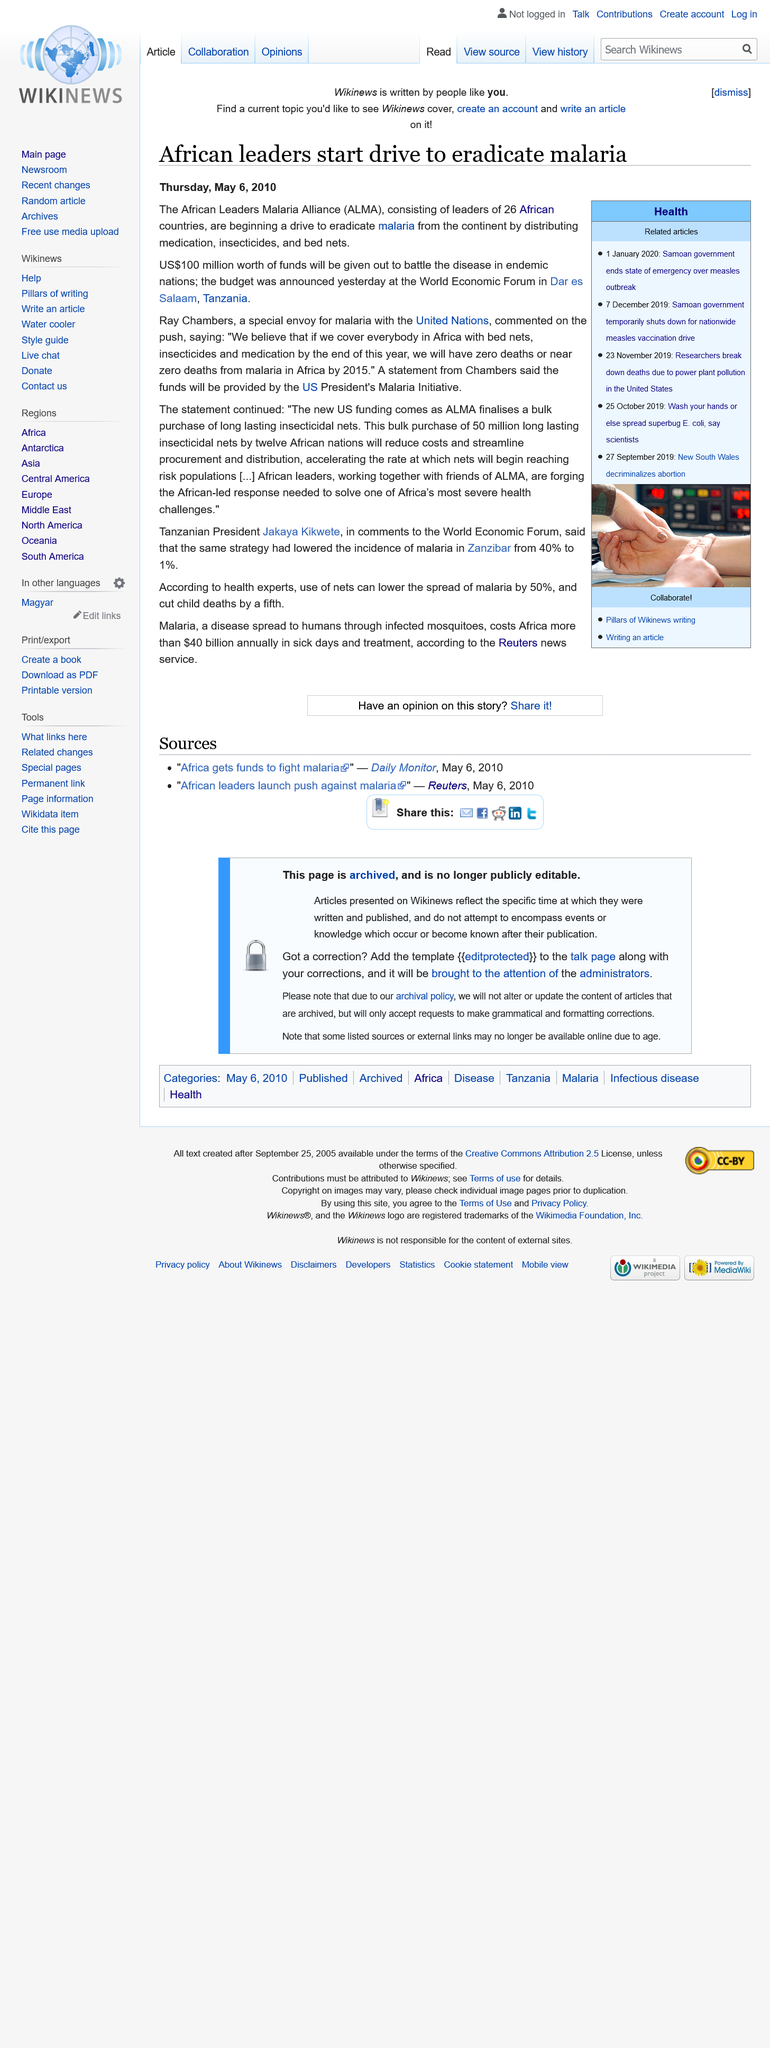Indicate a few pertinent items in this graphic. The African Leaders Malaria Alliance consists of the leaders of 26 African countries who come together to combat malaria on the continent. The African Leaders Malaria Alliance (ALMA) is distributing medication, insecticides, and bed nets as part of a campaign to eradicate malaria in Africa. It is estimated that 100 million USD worth of funds are being utilized in the efforts to combat Malaria in endemic nations. 